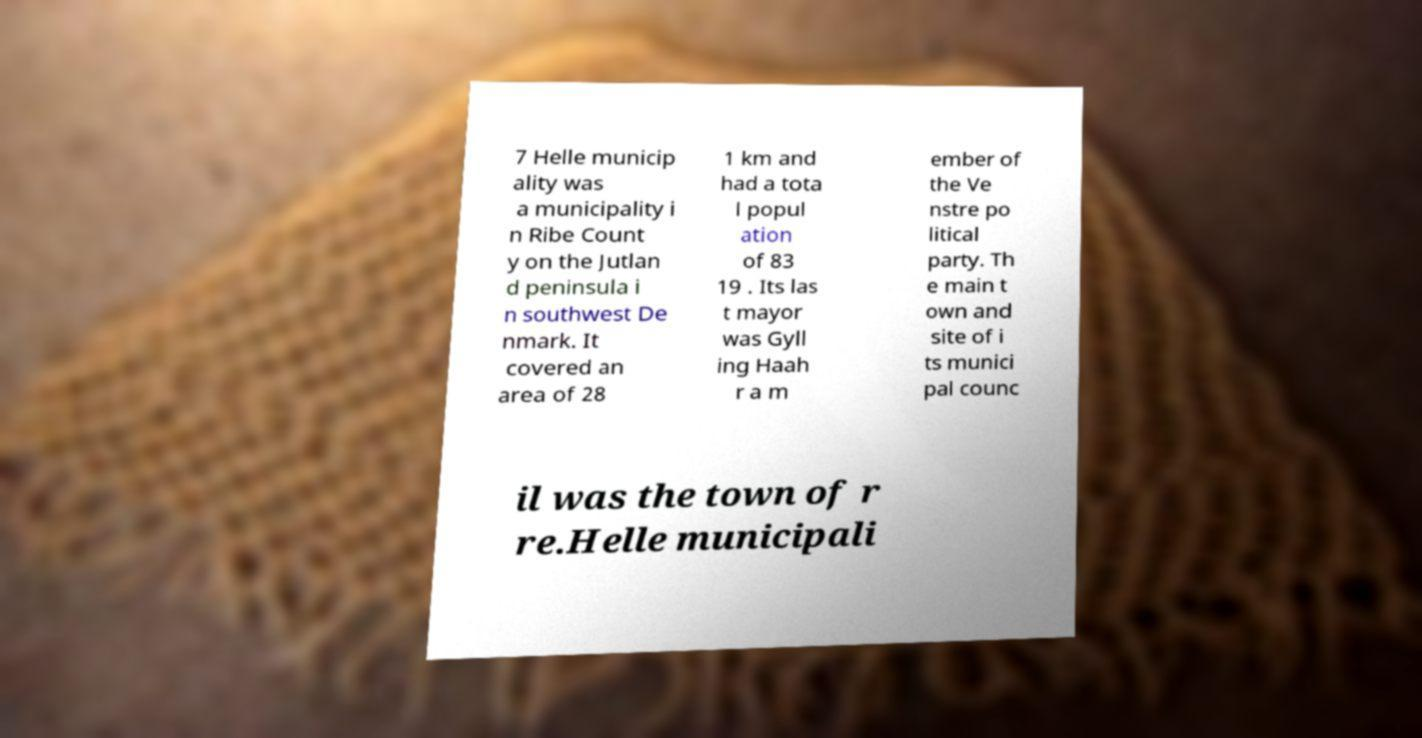Could you assist in decoding the text presented in this image and type it out clearly? 7 Helle municip ality was a municipality i n Ribe Count y on the Jutlan d peninsula i n southwest De nmark. It covered an area of 28 1 km and had a tota l popul ation of 83 19 . Its las t mayor was Gyll ing Haah r a m ember of the Ve nstre po litical party. Th e main t own and site of i ts munici pal counc il was the town of r re.Helle municipali 